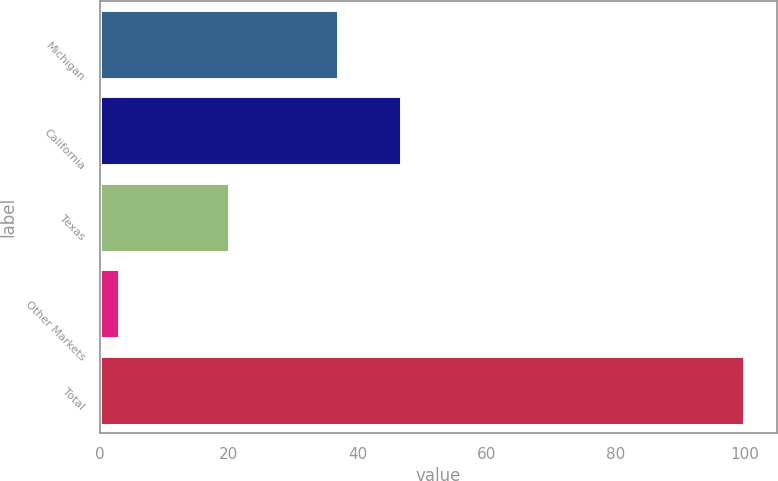<chart> <loc_0><loc_0><loc_500><loc_500><bar_chart><fcel>Michigan<fcel>California<fcel>Texas<fcel>Other Markets<fcel>Total<nl><fcel>37<fcel>46.7<fcel>20<fcel>3<fcel>100<nl></chart> 